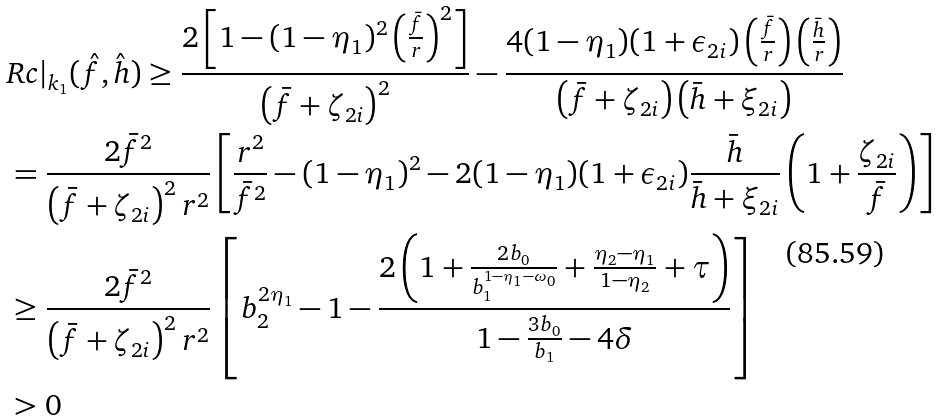Convert formula to latex. <formula><loc_0><loc_0><loc_500><loc_500>& R c | _ { k _ { 1 } } ( \hat { f } , \hat { h } ) \geq \frac { 2 \left [ 1 - ( 1 - \eta _ { 1 } ) ^ { 2 } \left ( \frac { \bar { f } } { r } \right ) ^ { 2 } \right ] } { \left ( \bar { f } + \zeta _ { 2 i } \right ) ^ { 2 } } - \frac { 4 ( 1 - \eta _ { 1 } ) ( 1 + \epsilon _ { 2 i } ) \left ( \frac { \bar { f } } { r } \right ) \left ( \frac { \bar { h } } { r } \right ) } { \left ( \bar { f } + \zeta _ { 2 i } \right ) \left ( \bar { h } + \xi _ { 2 i } \right ) } \\ & = \frac { 2 \bar { f } ^ { 2 } } { \left ( \bar { f } + \zeta _ { 2 i } \right ) ^ { 2 } r ^ { 2 } } \left [ \frac { r ^ { 2 } } { \bar { f } ^ { 2 } } - ( 1 - \eta _ { 1 } ) ^ { 2 } - 2 ( 1 - \eta _ { 1 } ) ( 1 + \epsilon _ { 2 i } ) \frac { \bar { h } } { \bar { h } + \xi _ { 2 i } } \left ( 1 + \frac { \zeta _ { 2 i } } { \bar { f } } \right ) \right ] \\ & \geq \frac { 2 \bar { f } ^ { 2 } } { \left ( \bar { f } + \zeta _ { 2 i } \right ) ^ { 2 } r ^ { 2 } } \left [ b _ { 2 } ^ { 2 \eta _ { 1 } } - 1 - \frac { 2 \left ( 1 + \frac { 2 b _ { 0 } } { b _ { 1 } ^ { 1 - \eta _ { 1 } - \omega _ { 0 } } } + \frac { \eta _ { 2 } - \eta _ { 1 } } { 1 - \eta _ { 2 } } + \tau \right ) } { 1 - \frac { 3 b _ { 0 } } { b _ { 1 } } - 4 \delta } \right ] \\ & > 0</formula> 